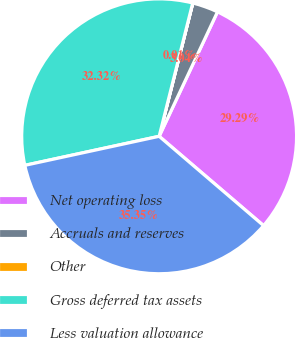<chart> <loc_0><loc_0><loc_500><loc_500><pie_chart><fcel>Net operating loss<fcel>Accruals and reserves<fcel>Other<fcel>Gross deferred tax assets<fcel>Less valuation allowance<nl><fcel>29.29%<fcel>3.04%<fcel>0.01%<fcel>32.32%<fcel>35.35%<nl></chart> 